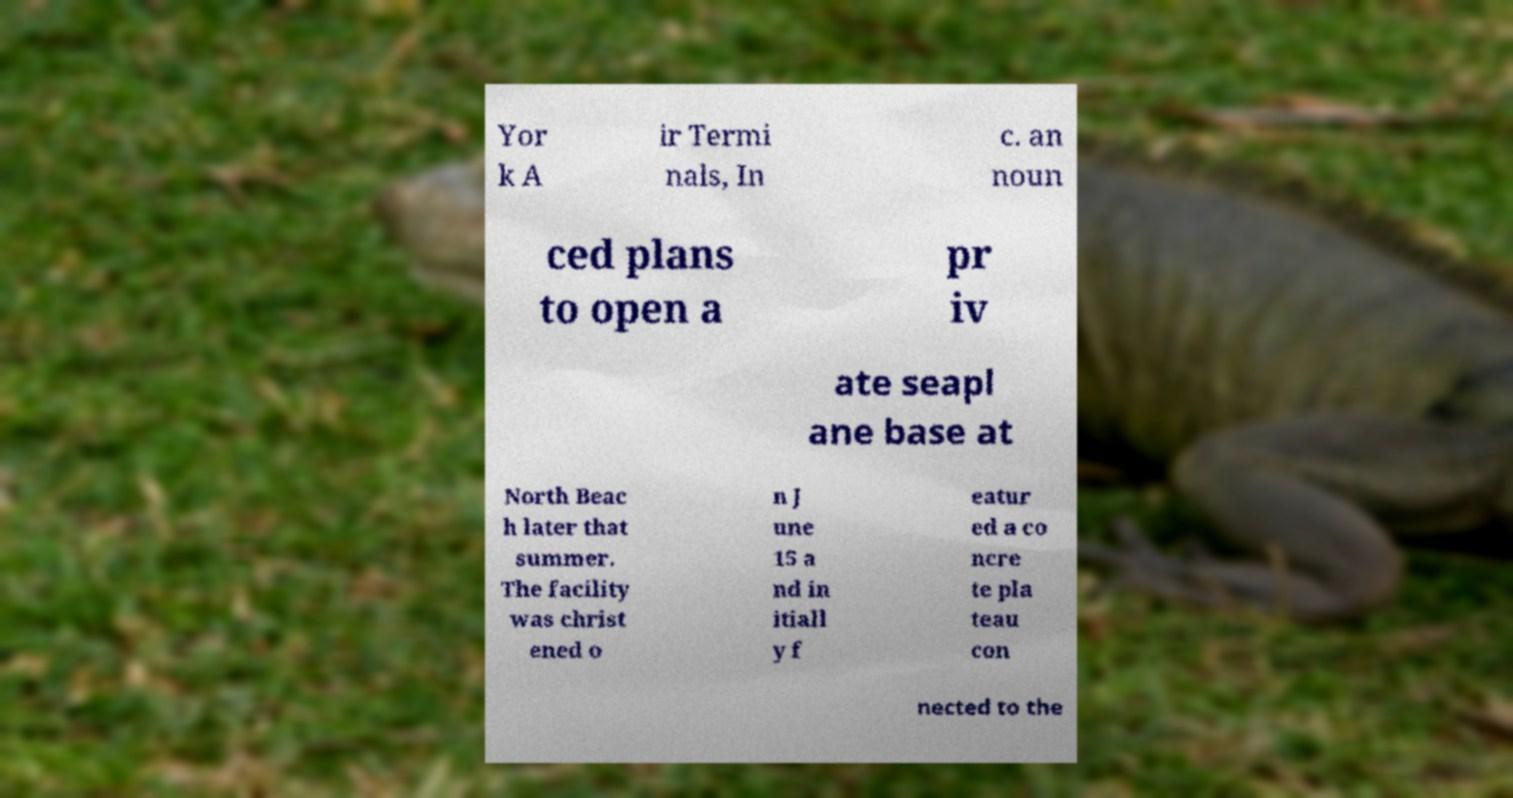What messages or text are displayed in this image? I need them in a readable, typed format. Yor k A ir Termi nals, In c. an noun ced plans to open a pr iv ate seapl ane base at North Beac h later that summer. The facility was christ ened o n J une 15 a nd in itiall y f eatur ed a co ncre te pla teau con nected to the 